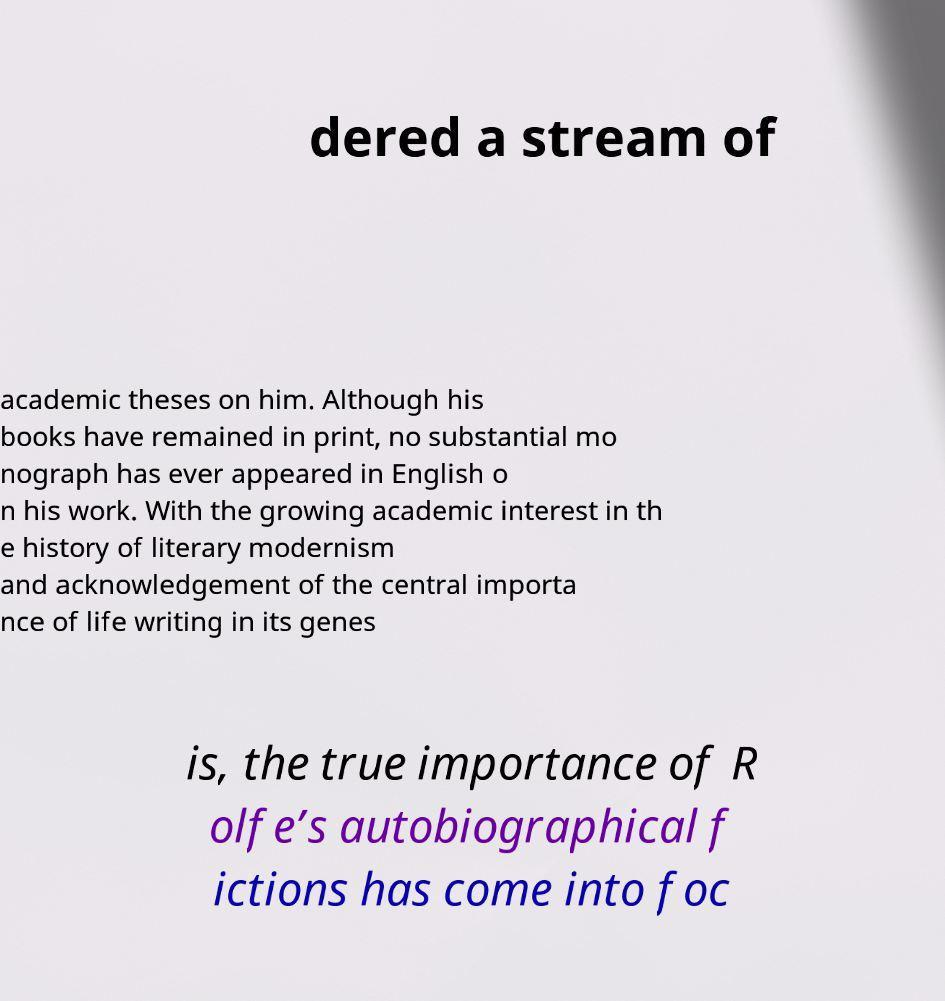What messages or text are displayed in this image? I need them in a readable, typed format. dered a stream of academic theses on him. Although his books have remained in print, no substantial mo nograph has ever appeared in English o n his work. With the growing academic interest in th e history of literary modernism and acknowledgement of the central importa nce of life writing in its genes is, the true importance of R olfe’s autobiographical f ictions has come into foc 